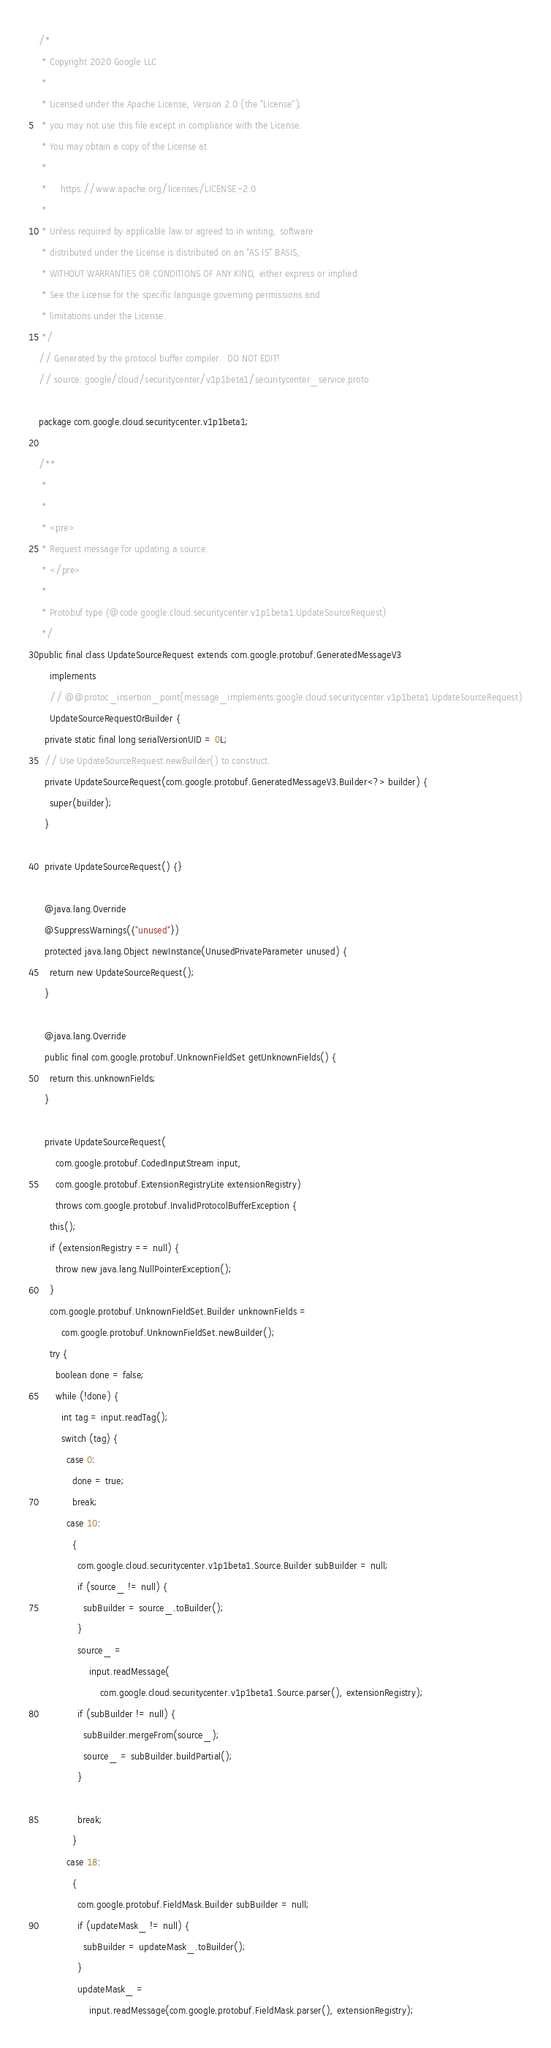Convert code to text. <code><loc_0><loc_0><loc_500><loc_500><_Java_>/*
 * Copyright 2020 Google LLC
 *
 * Licensed under the Apache License, Version 2.0 (the "License");
 * you may not use this file except in compliance with the License.
 * You may obtain a copy of the License at
 *
 *     https://www.apache.org/licenses/LICENSE-2.0
 *
 * Unless required by applicable law or agreed to in writing, software
 * distributed under the License is distributed on an "AS IS" BASIS,
 * WITHOUT WARRANTIES OR CONDITIONS OF ANY KIND, either express or implied.
 * See the License for the specific language governing permissions and
 * limitations under the License.
 */
// Generated by the protocol buffer compiler.  DO NOT EDIT!
// source: google/cloud/securitycenter/v1p1beta1/securitycenter_service.proto

package com.google.cloud.securitycenter.v1p1beta1;

/**
 *
 *
 * <pre>
 * Request message for updating a source.
 * </pre>
 *
 * Protobuf type {@code google.cloud.securitycenter.v1p1beta1.UpdateSourceRequest}
 */
public final class UpdateSourceRequest extends com.google.protobuf.GeneratedMessageV3
    implements
    // @@protoc_insertion_point(message_implements:google.cloud.securitycenter.v1p1beta1.UpdateSourceRequest)
    UpdateSourceRequestOrBuilder {
  private static final long serialVersionUID = 0L;
  // Use UpdateSourceRequest.newBuilder() to construct.
  private UpdateSourceRequest(com.google.protobuf.GeneratedMessageV3.Builder<?> builder) {
    super(builder);
  }

  private UpdateSourceRequest() {}

  @java.lang.Override
  @SuppressWarnings({"unused"})
  protected java.lang.Object newInstance(UnusedPrivateParameter unused) {
    return new UpdateSourceRequest();
  }

  @java.lang.Override
  public final com.google.protobuf.UnknownFieldSet getUnknownFields() {
    return this.unknownFields;
  }

  private UpdateSourceRequest(
      com.google.protobuf.CodedInputStream input,
      com.google.protobuf.ExtensionRegistryLite extensionRegistry)
      throws com.google.protobuf.InvalidProtocolBufferException {
    this();
    if (extensionRegistry == null) {
      throw new java.lang.NullPointerException();
    }
    com.google.protobuf.UnknownFieldSet.Builder unknownFields =
        com.google.protobuf.UnknownFieldSet.newBuilder();
    try {
      boolean done = false;
      while (!done) {
        int tag = input.readTag();
        switch (tag) {
          case 0:
            done = true;
            break;
          case 10:
            {
              com.google.cloud.securitycenter.v1p1beta1.Source.Builder subBuilder = null;
              if (source_ != null) {
                subBuilder = source_.toBuilder();
              }
              source_ =
                  input.readMessage(
                      com.google.cloud.securitycenter.v1p1beta1.Source.parser(), extensionRegistry);
              if (subBuilder != null) {
                subBuilder.mergeFrom(source_);
                source_ = subBuilder.buildPartial();
              }

              break;
            }
          case 18:
            {
              com.google.protobuf.FieldMask.Builder subBuilder = null;
              if (updateMask_ != null) {
                subBuilder = updateMask_.toBuilder();
              }
              updateMask_ =
                  input.readMessage(com.google.protobuf.FieldMask.parser(), extensionRegistry);</code> 